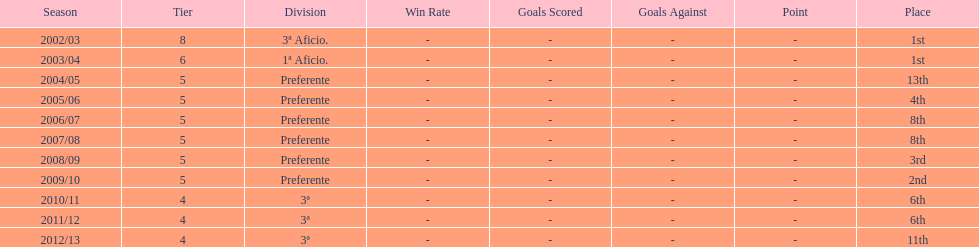What place was 1a aficio and 3a aficio? 1st. 